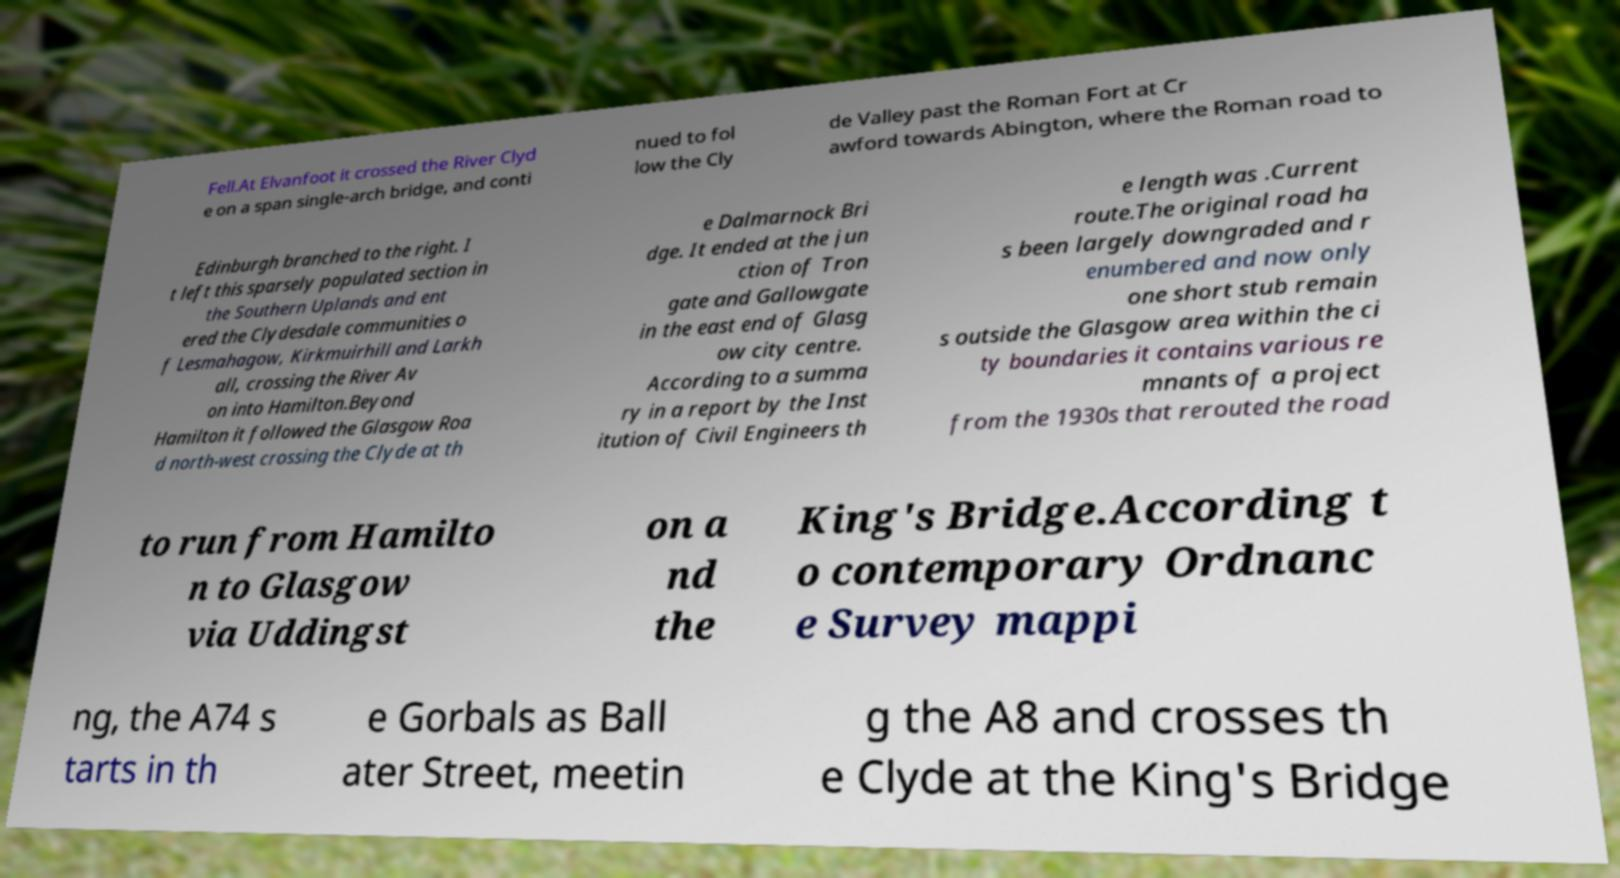Please read and relay the text visible in this image. What does it say? Fell.At Elvanfoot it crossed the River Clyd e on a span single-arch bridge, and conti nued to fol low the Cly de Valley past the Roman Fort at Cr awford towards Abington, where the Roman road to Edinburgh branched to the right. I t left this sparsely populated section in the Southern Uplands and ent ered the Clydesdale communities o f Lesmahagow, Kirkmuirhill and Larkh all, crossing the River Av on into Hamilton.Beyond Hamilton it followed the Glasgow Roa d north-west crossing the Clyde at th e Dalmarnock Bri dge. It ended at the jun ction of Tron gate and Gallowgate in the east end of Glasg ow city centre. According to a summa ry in a report by the Inst itution of Civil Engineers th e length was .Current route.The original road ha s been largely downgraded and r enumbered and now only one short stub remain s outside the Glasgow area within the ci ty boundaries it contains various re mnants of a project from the 1930s that rerouted the road to run from Hamilto n to Glasgow via Uddingst on a nd the King's Bridge.According t o contemporary Ordnanc e Survey mappi ng, the A74 s tarts in th e Gorbals as Ball ater Street, meetin g the A8 and crosses th e Clyde at the King's Bridge 